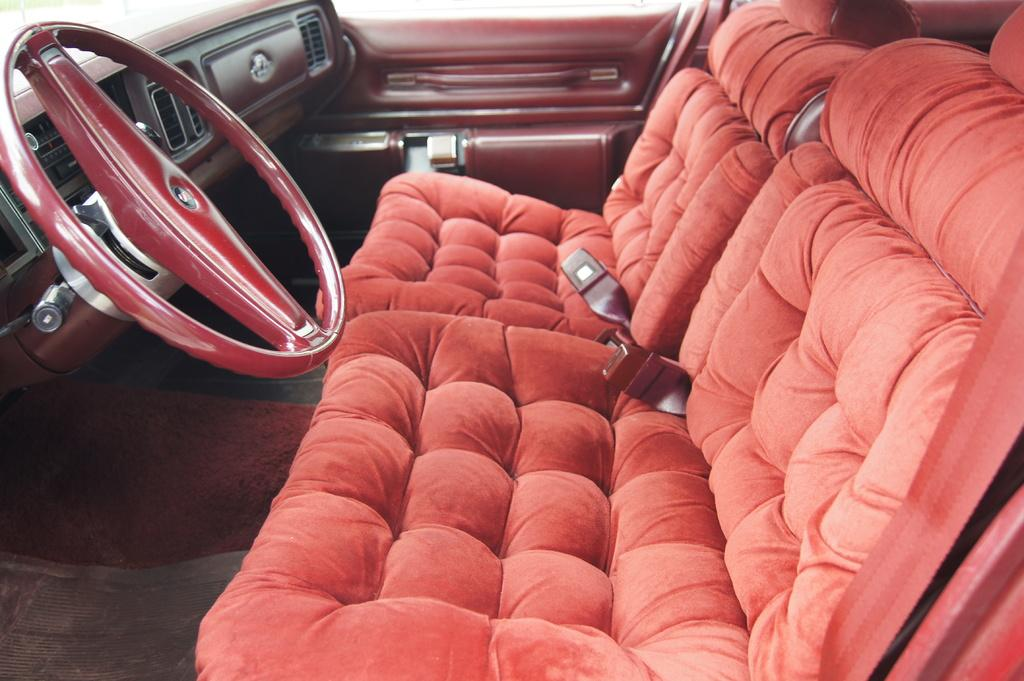What type of setting is depicted in the image? The image is an inside view of a vehicle. What can be found inside the vehicle? There are seats in the vehicle. What is used to control the direction of the vehicle? There is a steering wheel in the vehicle. What type of vase can be seen on the dashboard of the vehicle? There is no vase present on the dashboard of the vehicle in the image. 